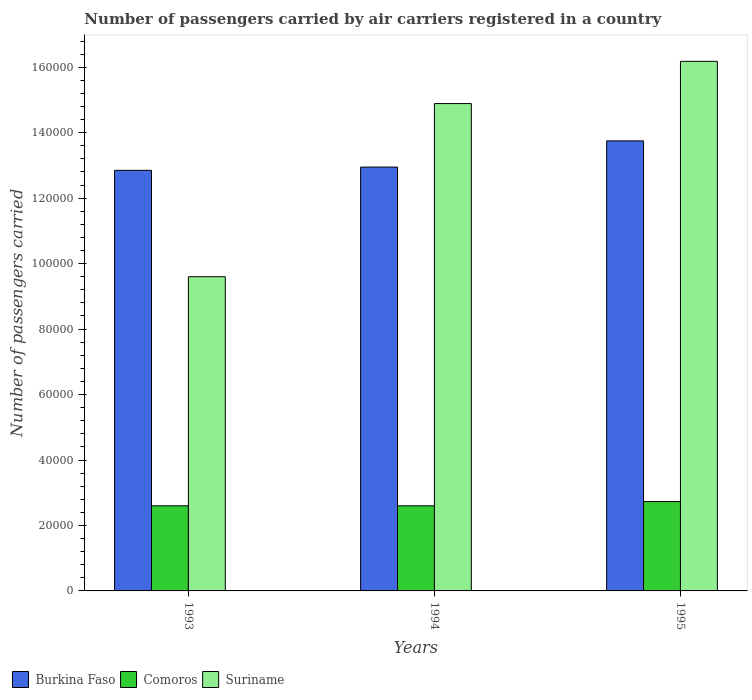How many groups of bars are there?
Provide a short and direct response. 3. Are the number of bars per tick equal to the number of legend labels?
Your response must be concise. Yes. How many bars are there on the 1st tick from the left?
Provide a short and direct response. 3. How many bars are there on the 1st tick from the right?
Offer a very short reply. 3. In how many cases, is the number of bars for a given year not equal to the number of legend labels?
Your answer should be compact. 0. What is the number of passengers carried by air carriers in Suriname in 1994?
Your answer should be compact. 1.49e+05. Across all years, what is the maximum number of passengers carried by air carriers in Burkina Faso?
Make the answer very short. 1.38e+05. Across all years, what is the minimum number of passengers carried by air carriers in Comoros?
Your answer should be compact. 2.60e+04. In which year was the number of passengers carried by air carriers in Burkina Faso maximum?
Give a very brief answer. 1995. What is the total number of passengers carried by air carriers in Burkina Faso in the graph?
Offer a terse response. 3.96e+05. What is the difference between the number of passengers carried by air carriers in Suriname in 1993 and that in 1995?
Your answer should be very brief. -6.58e+04. What is the difference between the number of passengers carried by air carriers in Burkina Faso in 1993 and the number of passengers carried by air carriers in Suriname in 1994?
Offer a very short reply. -2.04e+04. What is the average number of passengers carried by air carriers in Comoros per year?
Ensure brevity in your answer.  2.64e+04. In how many years, is the number of passengers carried by air carriers in Comoros greater than 148000?
Your answer should be compact. 0. What is the ratio of the number of passengers carried by air carriers in Suriname in 1993 to that in 1995?
Provide a short and direct response. 0.59. Is the difference between the number of passengers carried by air carriers in Comoros in 1993 and 1994 greater than the difference between the number of passengers carried by air carriers in Suriname in 1993 and 1994?
Your answer should be compact. Yes. What is the difference between the highest and the second highest number of passengers carried by air carriers in Suriname?
Make the answer very short. 1.29e+04. What is the difference between the highest and the lowest number of passengers carried by air carriers in Comoros?
Your answer should be compact. 1300. In how many years, is the number of passengers carried by air carriers in Suriname greater than the average number of passengers carried by air carriers in Suriname taken over all years?
Your answer should be very brief. 2. What does the 3rd bar from the left in 1994 represents?
Provide a short and direct response. Suriname. What does the 1st bar from the right in 1994 represents?
Provide a short and direct response. Suriname. Is it the case that in every year, the sum of the number of passengers carried by air carriers in Comoros and number of passengers carried by air carriers in Burkina Faso is greater than the number of passengers carried by air carriers in Suriname?
Give a very brief answer. Yes. Are all the bars in the graph horizontal?
Offer a terse response. No. How many years are there in the graph?
Make the answer very short. 3. Does the graph contain any zero values?
Your answer should be compact. No. How many legend labels are there?
Keep it short and to the point. 3. How are the legend labels stacked?
Ensure brevity in your answer.  Horizontal. What is the title of the graph?
Offer a terse response. Number of passengers carried by air carriers registered in a country. Does "Greenland" appear as one of the legend labels in the graph?
Keep it short and to the point. No. What is the label or title of the X-axis?
Make the answer very short. Years. What is the label or title of the Y-axis?
Your answer should be compact. Number of passengers carried. What is the Number of passengers carried of Burkina Faso in 1993?
Your response must be concise. 1.28e+05. What is the Number of passengers carried in Comoros in 1993?
Your answer should be compact. 2.60e+04. What is the Number of passengers carried in Suriname in 1993?
Make the answer very short. 9.60e+04. What is the Number of passengers carried in Burkina Faso in 1994?
Provide a short and direct response. 1.30e+05. What is the Number of passengers carried of Comoros in 1994?
Offer a very short reply. 2.60e+04. What is the Number of passengers carried in Suriname in 1994?
Provide a short and direct response. 1.49e+05. What is the Number of passengers carried of Burkina Faso in 1995?
Give a very brief answer. 1.38e+05. What is the Number of passengers carried in Comoros in 1995?
Offer a terse response. 2.73e+04. What is the Number of passengers carried of Suriname in 1995?
Offer a very short reply. 1.62e+05. Across all years, what is the maximum Number of passengers carried of Burkina Faso?
Provide a short and direct response. 1.38e+05. Across all years, what is the maximum Number of passengers carried of Comoros?
Your answer should be very brief. 2.73e+04. Across all years, what is the maximum Number of passengers carried of Suriname?
Keep it short and to the point. 1.62e+05. Across all years, what is the minimum Number of passengers carried in Burkina Faso?
Offer a very short reply. 1.28e+05. Across all years, what is the minimum Number of passengers carried of Comoros?
Your answer should be very brief. 2.60e+04. Across all years, what is the minimum Number of passengers carried in Suriname?
Provide a succinct answer. 9.60e+04. What is the total Number of passengers carried in Burkina Faso in the graph?
Offer a terse response. 3.96e+05. What is the total Number of passengers carried of Comoros in the graph?
Provide a short and direct response. 7.93e+04. What is the total Number of passengers carried of Suriname in the graph?
Give a very brief answer. 4.07e+05. What is the difference between the Number of passengers carried in Burkina Faso in 1993 and that in 1994?
Provide a succinct answer. -1000. What is the difference between the Number of passengers carried of Comoros in 1993 and that in 1994?
Keep it short and to the point. 0. What is the difference between the Number of passengers carried of Suriname in 1993 and that in 1994?
Offer a very short reply. -5.29e+04. What is the difference between the Number of passengers carried of Burkina Faso in 1993 and that in 1995?
Offer a terse response. -9000. What is the difference between the Number of passengers carried of Comoros in 1993 and that in 1995?
Keep it short and to the point. -1300. What is the difference between the Number of passengers carried of Suriname in 1993 and that in 1995?
Make the answer very short. -6.58e+04. What is the difference between the Number of passengers carried in Burkina Faso in 1994 and that in 1995?
Your response must be concise. -8000. What is the difference between the Number of passengers carried in Comoros in 1994 and that in 1995?
Provide a short and direct response. -1300. What is the difference between the Number of passengers carried in Suriname in 1994 and that in 1995?
Your response must be concise. -1.29e+04. What is the difference between the Number of passengers carried of Burkina Faso in 1993 and the Number of passengers carried of Comoros in 1994?
Offer a very short reply. 1.02e+05. What is the difference between the Number of passengers carried in Burkina Faso in 1993 and the Number of passengers carried in Suriname in 1994?
Provide a short and direct response. -2.04e+04. What is the difference between the Number of passengers carried of Comoros in 1993 and the Number of passengers carried of Suriname in 1994?
Your answer should be compact. -1.23e+05. What is the difference between the Number of passengers carried of Burkina Faso in 1993 and the Number of passengers carried of Comoros in 1995?
Provide a short and direct response. 1.01e+05. What is the difference between the Number of passengers carried of Burkina Faso in 1993 and the Number of passengers carried of Suriname in 1995?
Keep it short and to the point. -3.33e+04. What is the difference between the Number of passengers carried in Comoros in 1993 and the Number of passengers carried in Suriname in 1995?
Make the answer very short. -1.36e+05. What is the difference between the Number of passengers carried of Burkina Faso in 1994 and the Number of passengers carried of Comoros in 1995?
Offer a very short reply. 1.02e+05. What is the difference between the Number of passengers carried of Burkina Faso in 1994 and the Number of passengers carried of Suriname in 1995?
Offer a terse response. -3.23e+04. What is the difference between the Number of passengers carried of Comoros in 1994 and the Number of passengers carried of Suriname in 1995?
Give a very brief answer. -1.36e+05. What is the average Number of passengers carried in Burkina Faso per year?
Your answer should be very brief. 1.32e+05. What is the average Number of passengers carried of Comoros per year?
Your answer should be compact. 2.64e+04. What is the average Number of passengers carried of Suriname per year?
Your answer should be compact. 1.36e+05. In the year 1993, what is the difference between the Number of passengers carried in Burkina Faso and Number of passengers carried in Comoros?
Your answer should be compact. 1.02e+05. In the year 1993, what is the difference between the Number of passengers carried of Burkina Faso and Number of passengers carried of Suriname?
Your answer should be very brief. 3.25e+04. In the year 1993, what is the difference between the Number of passengers carried of Comoros and Number of passengers carried of Suriname?
Your response must be concise. -7.00e+04. In the year 1994, what is the difference between the Number of passengers carried of Burkina Faso and Number of passengers carried of Comoros?
Provide a succinct answer. 1.04e+05. In the year 1994, what is the difference between the Number of passengers carried in Burkina Faso and Number of passengers carried in Suriname?
Your response must be concise. -1.94e+04. In the year 1994, what is the difference between the Number of passengers carried of Comoros and Number of passengers carried of Suriname?
Your response must be concise. -1.23e+05. In the year 1995, what is the difference between the Number of passengers carried of Burkina Faso and Number of passengers carried of Comoros?
Offer a very short reply. 1.10e+05. In the year 1995, what is the difference between the Number of passengers carried of Burkina Faso and Number of passengers carried of Suriname?
Offer a terse response. -2.43e+04. In the year 1995, what is the difference between the Number of passengers carried in Comoros and Number of passengers carried in Suriname?
Make the answer very short. -1.34e+05. What is the ratio of the Number of passengers carried of Comoros in 1993 to that in 1994?
Offer a very short reply. 1. What is the ratio of the Number of passengers carried of Suriname in 1993 to that in 1994?
Provide a short and direct response. 0.64. What is the ratio of the Number of passengers carried in Burkina Faso in 1993 to that in 1995?
Your response must be concise. 0.93. What is the ratio of the Number of passengers carried of Comoros in 1993 to that in 1995?
Offer a very short reply. 0.95. What is the ratio of the Number of passengers carried in Suriname in 1993 to that in 1995?
Ensure brevity in your answer.  0.59. What is the ratio of the Number of passengers carried of Burkina Faso in 1994 to that in 1995?
Offer a terse response. 0.94. What is the ratio of the Number of passengers carried in Suriname in 1994 to that in 1995?
Your answer should be compact. 0.92. What is the difference between the highest and the second highest Number of passengers carried in Burkina Faso?
Make the answer very short. 8000. What is the difference between the highest and the second highest Number of passengers carried in Comoros?
Ensure brevity in your answer.  1300. What is the difference between the highest and the second highest Number of passengers carried in Suriname?
Offer a very short reply. 1.29e+04. What is the difference between the highest and the lowest Number of passengers carried in Burkina Faso?
Offer a very short reply. 9000. What is the difference between the highest and the lowest Number of passengers carried in Comoros?
Your answer should be very brief. 1300. What is the difference between the highest and the lowest Number of passengers carried in Suriname?
Keep it short and to the point. 6.58e+04. 